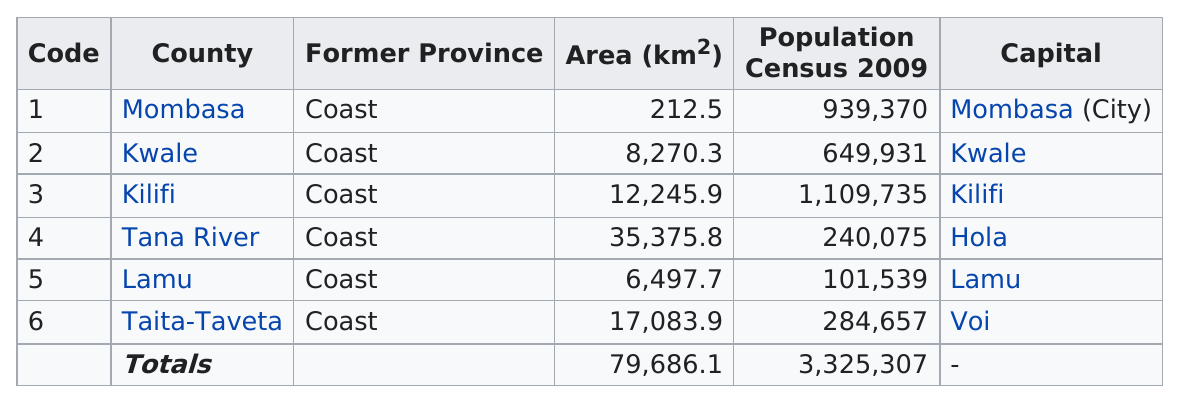Point out several critical features in this image. There are three counties in the United States with a population greater than 500,000. There were three counties in the United States with a population of over 500,000 in 2009. Mombasa County is the only one that has an area less than 1,000 square kilometers. Of the counties, there are three that are smaller than 10,000 square kilometers. Based on available data, the counties with a land area larger than Kilifi are Tana River and Taita-Taveta. 